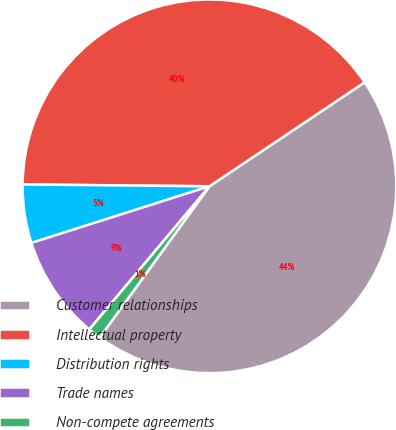Convert chart. <chart><loc_0><loc_0><loc_500><loc_500><pie_chart><fcel>Customer relationships<fcel>Intellectual property<fcel>Distribution rights<fcel>Trade names<fcel>Non-compete agreements<nl><fcel>44.39%<fcel>40.45%<fcel>5.06%<fcel>8.99%<fcel>1.12%<nl></chart> 